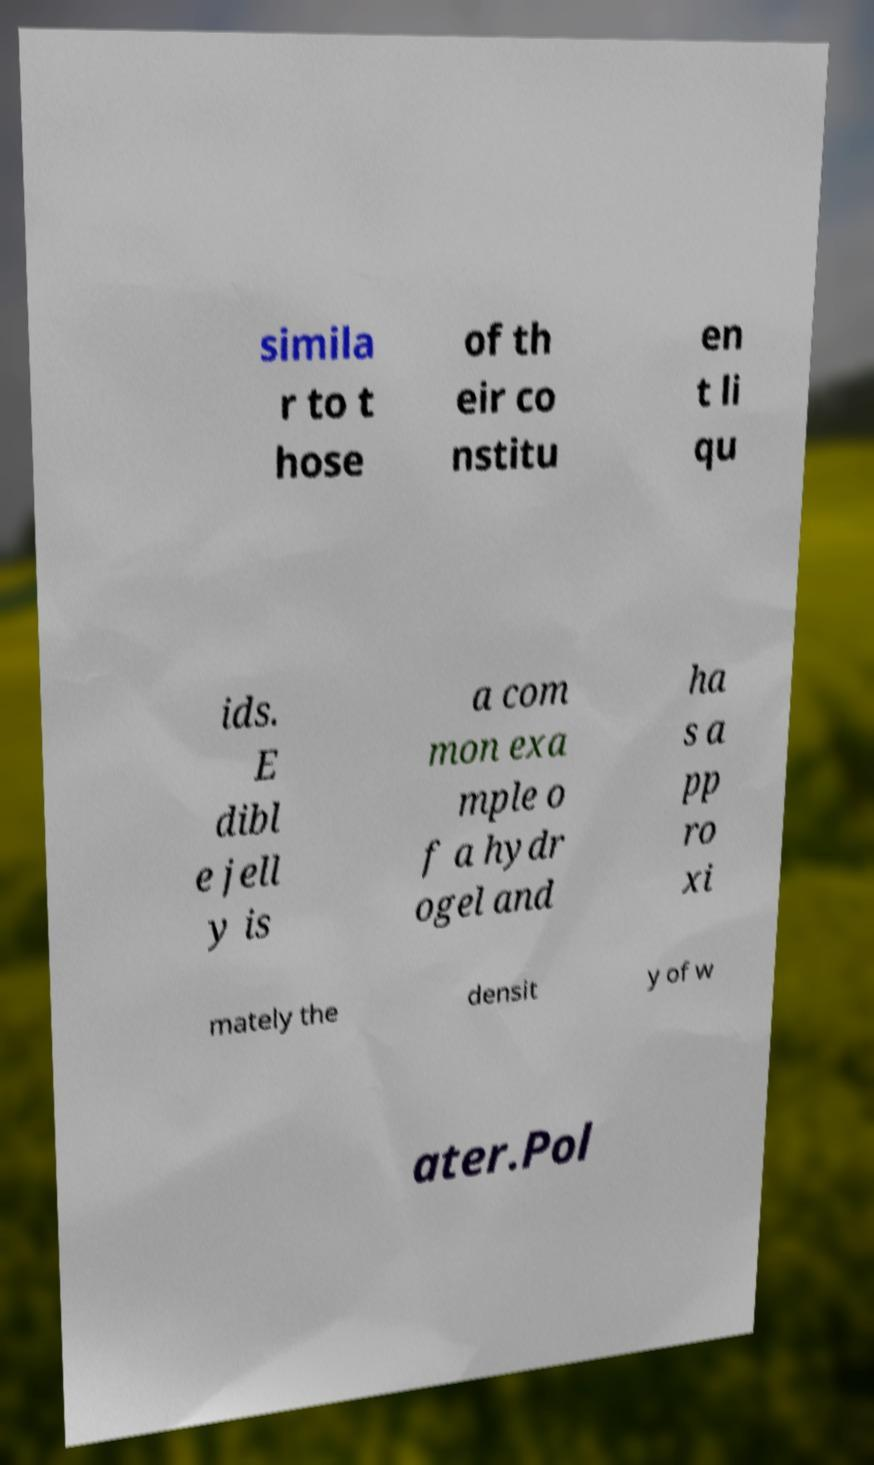Can you accurately transcribe the text from the provided image for me? simila r to t hose of th eir co nstitu en t li qu ids. E dibl e jell y is a com mon exa mple o f a hydr ogel and ha s a pp ro xi mately the densit y of w ater.Pol 